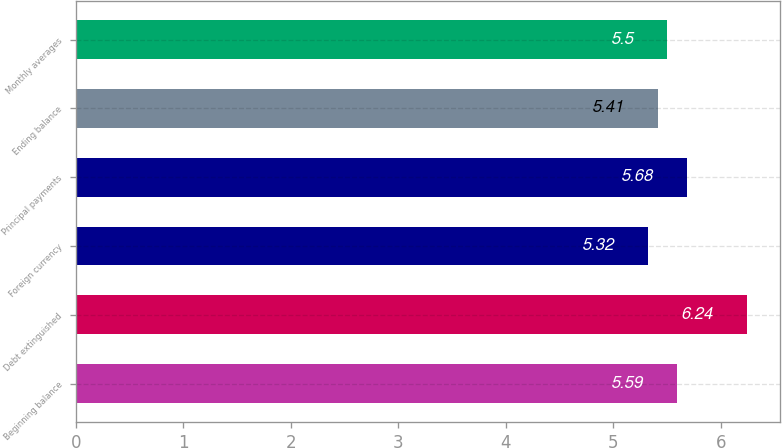Convert chart. <chart><loc_0><loc_0><loc_500><loc_500><bar_chart><fcel>Beginning balance<fcel>Debt extinguished<fcel>Foreign currency<fcel>Principal payments<fcel>Ending balance<fcel>Monthly averages<nl><fcel>5.59<fcel>6.24<fcel>5.32<fcel>5.68<fcel>5.41<fcel>5.5<nl></chart> 